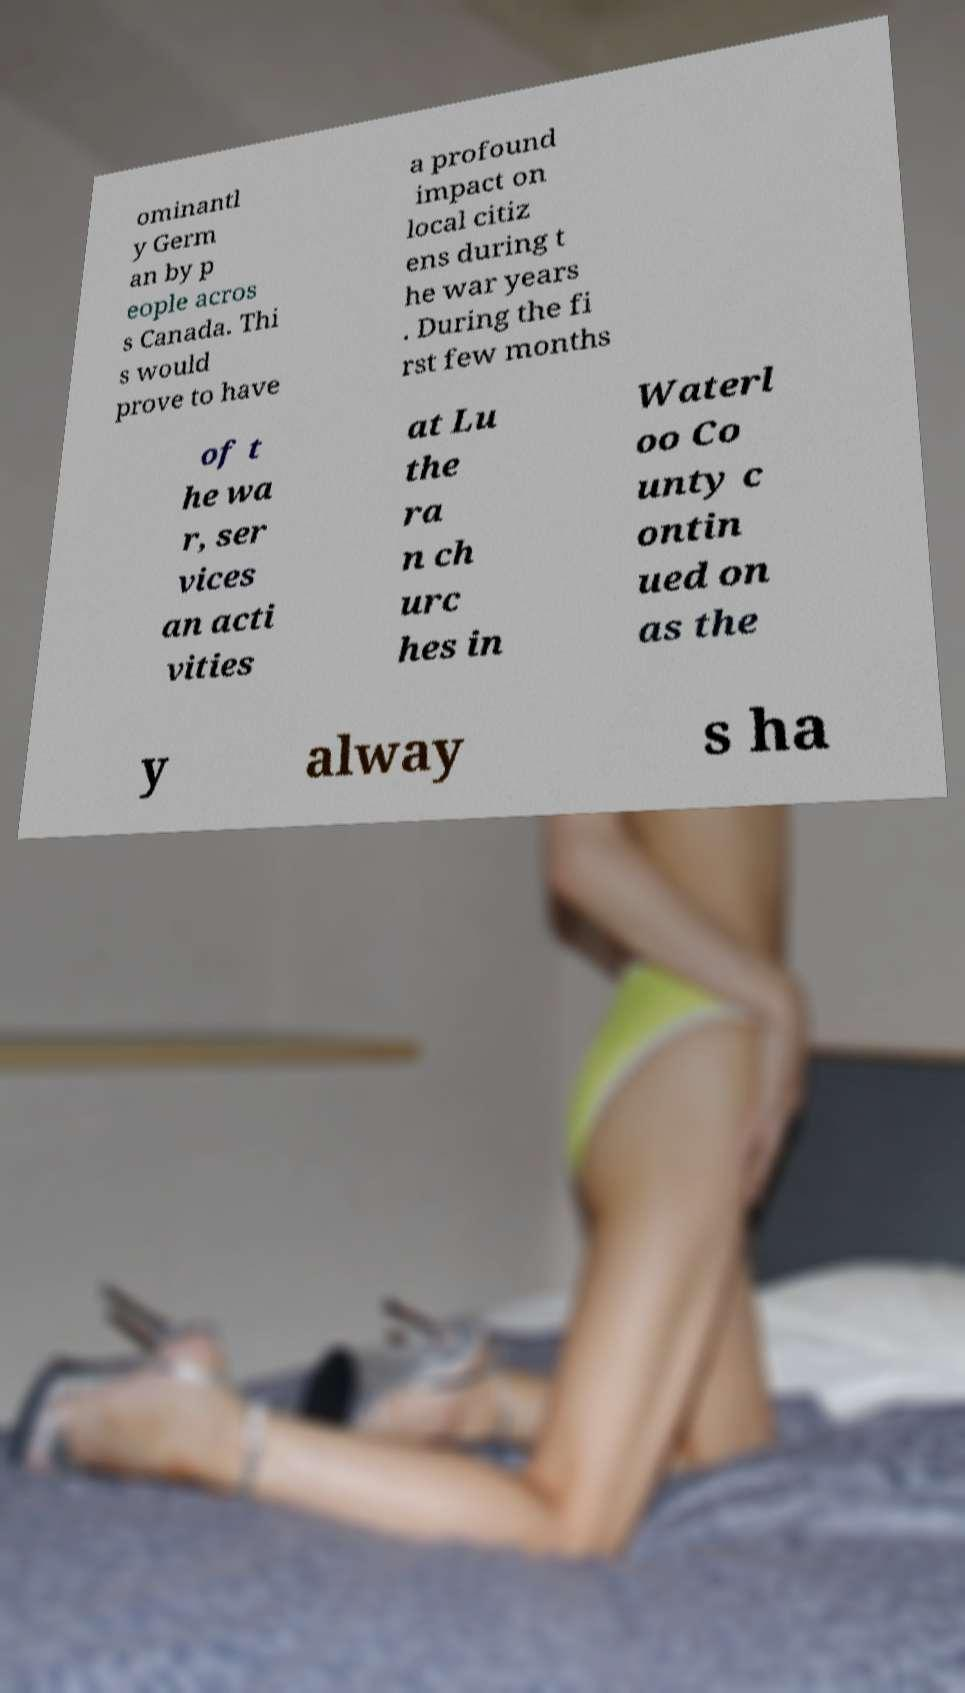Can you read and provide the text displayed in the image?This photo seems to have some interesting text. Can you extract and type it out for me? ominantl y Germ an by p eople acros s Canada. Thi s would prove to have a profound impact on local citiz ens during t he war years . During the fi rst few months of t he wa r, ser vices an acti vities at Lu the ra n ch urc hes in Waterl oo Co unty c ontin ued on as the y alway s ha 